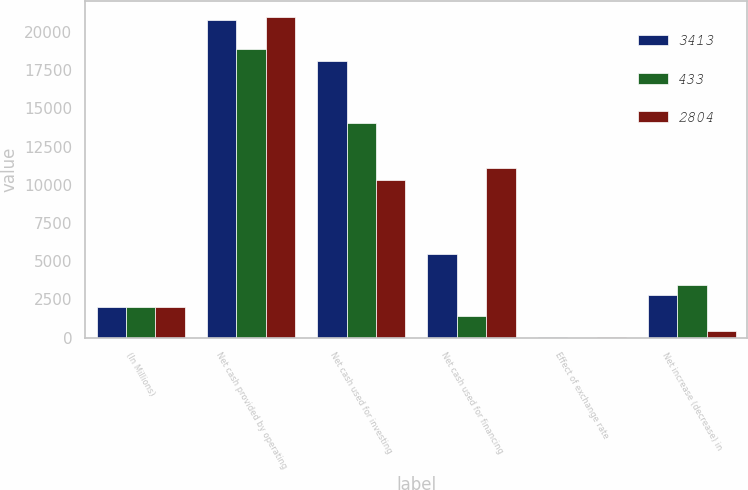<chart> <loc_0><loc_0><loc_500><loc_500><stacked_bar_chart><ecel><fcel>(In Millions)<fcel>Net cash provided by operating<fcel>Net cash used for investing<fcel>Net cash used for financing<fcel>Effect of exchange rate<fcel>Net increase (decrease) in<nl><fcel>3413<fcel>2013<fcel>20776<fcel>18073<fcel>5498<fcel>9<fcel>2804<nl><fcel>433<fcel>2012<fcel>18884<fcel>14060<fcel>1408<fcel>3<fcel>3413<nl><fcel>2804<fcel>2011<fcel>20963<fcel>10301<fcel>11100<fcel>5<fcel>433<nl></chart> 